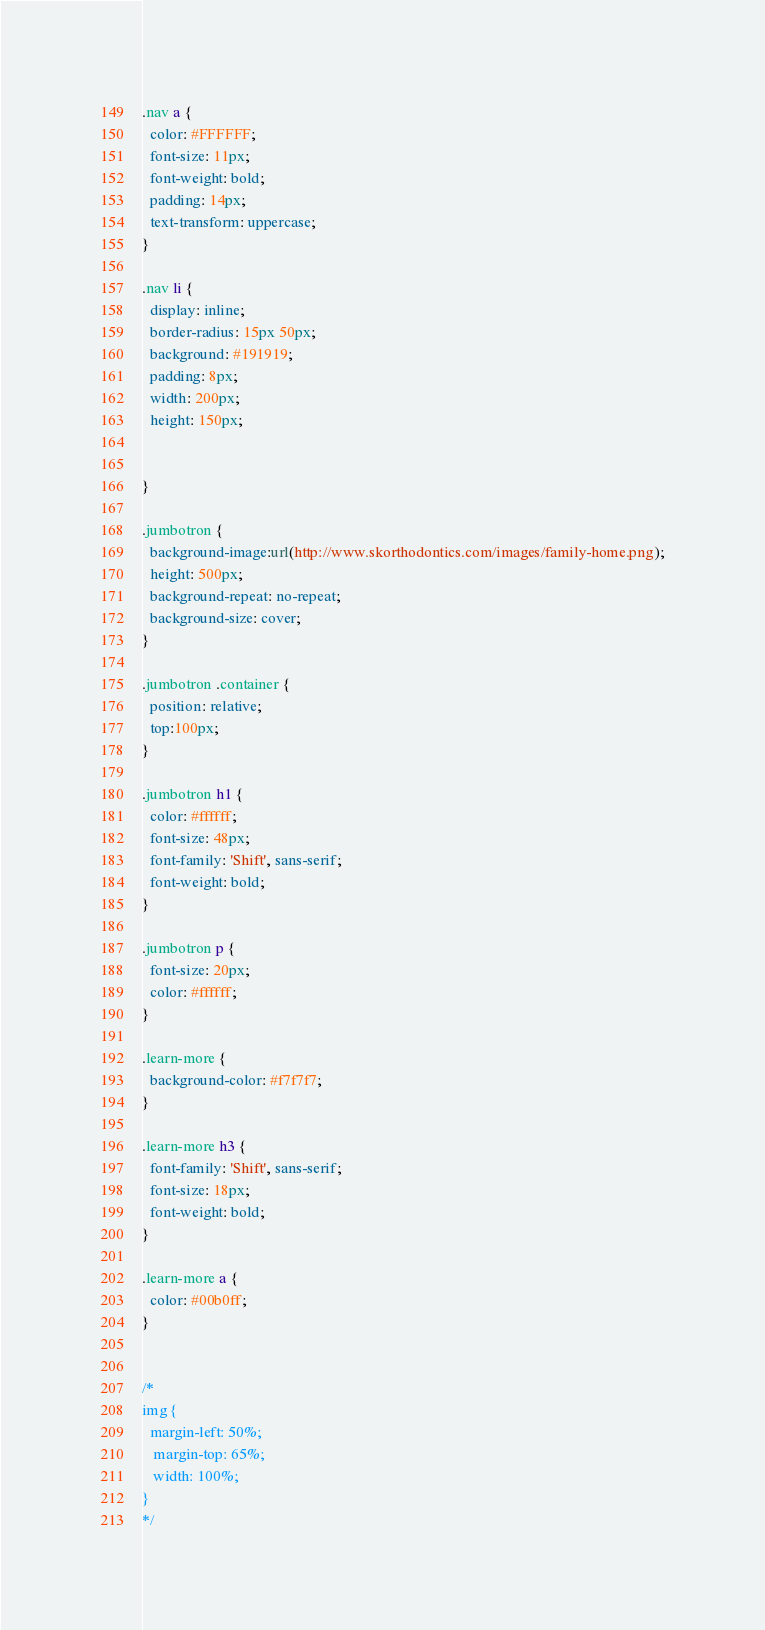<code> <loc_0><loc_0><loc_500><loc_500><_CSS_>.nav a {
  color: #FFFFFF;
  font-size: 11px;
  font-weight: bold;
  padding: 14px;
  text-transform: uppercase;
}

.nav li {
  display: inline;
  border-radius: 15px 50px;
  background: #191919;
  padding: 8px; 
  width: 200px;
  height: 150px; 
  
   
}

.jumbotron {
  background-image:url(http://www.skorthodontics.com/images/family-home.png);
  height: 500px;
  background-repeat: no-repeat;
  background-size: cover;
}

.jumbotron .container {
  position: relative;
  top:100px;
}

.jumbotron h1 {
  color: #ffffff;
  font-size: 48px;  
  font-family: 'Shift', sans-serif;
  font-weight: bold;
}

.jumbotron p {
  font-size: 20px;
  color: #ffffff;
}

.learn-more {
  background-color: #f7f7f7;
}

.learn-more h3 {
  font-family: 'Shift', sans-serif;
  font-size: 18px;
  font-weight: bold;
}

.learn-more a {
  color: #00b0ff;
}


/*
img {
  margin-left: 50%;
   margin-top: 65%;
   width: 100%;
}
*/
</code> 